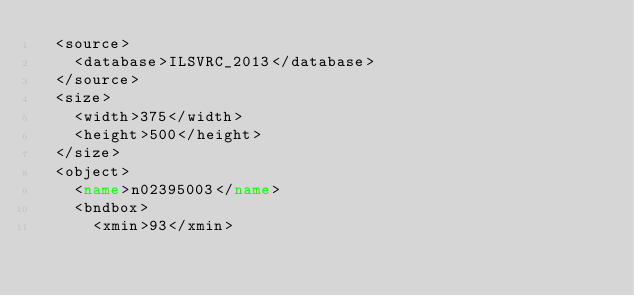<code> <loc_0><loc_0><loc_500><loc_500><_XML_>	<source>
		<database>ILSVRC_2013</database>
	</source>
	<size>
		<width>375</width>
		<height>500</height>
	</size>
	<object>
		<name>n02395003</name>
		<bndbox>
			<xmin>93</xmin></code> 